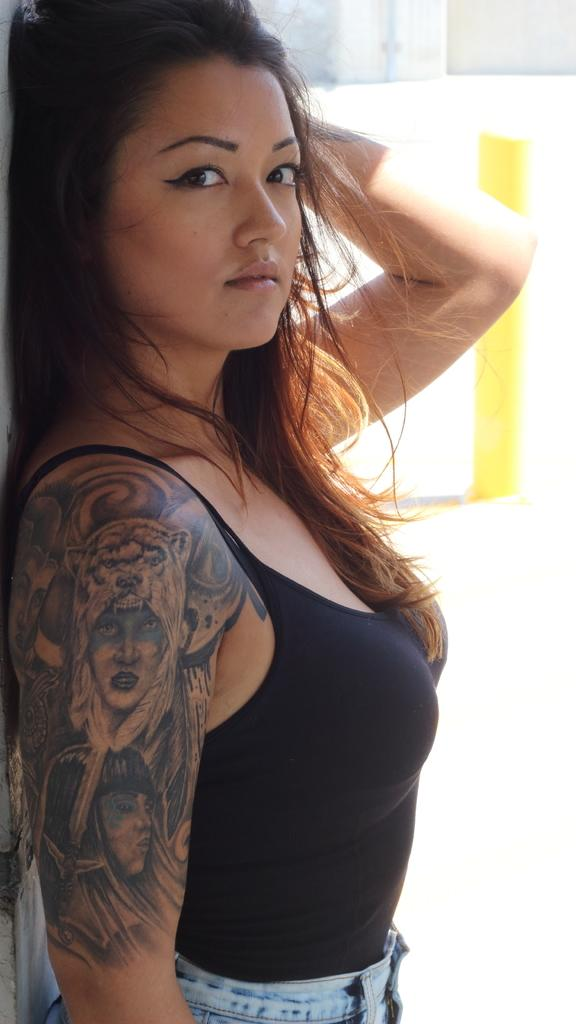What is the main subject of the image? There is a picture of a girl in the image. Can you describe any distinguishing features of the girl? The girl has a tattoo on her right hand. What can be seen in the background of the image? There is a wall in the background of the image. How does the girl's breath affect the temperature in the image? There is no information about the girl's breath or the temperature in the image, so we cannot determine its effect. 